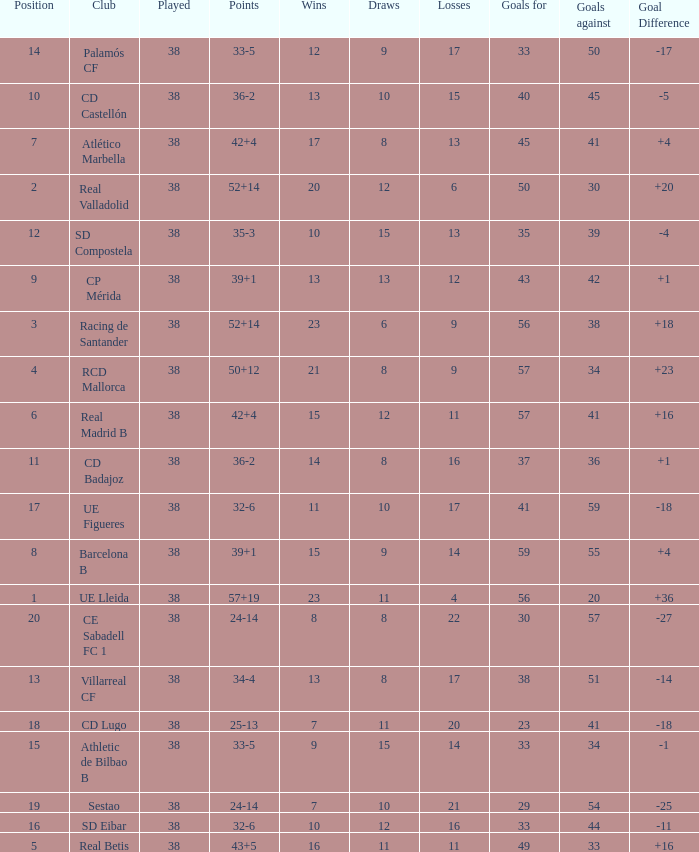What is the highest number of loss with a 7 position and more than 45 goals? None. 